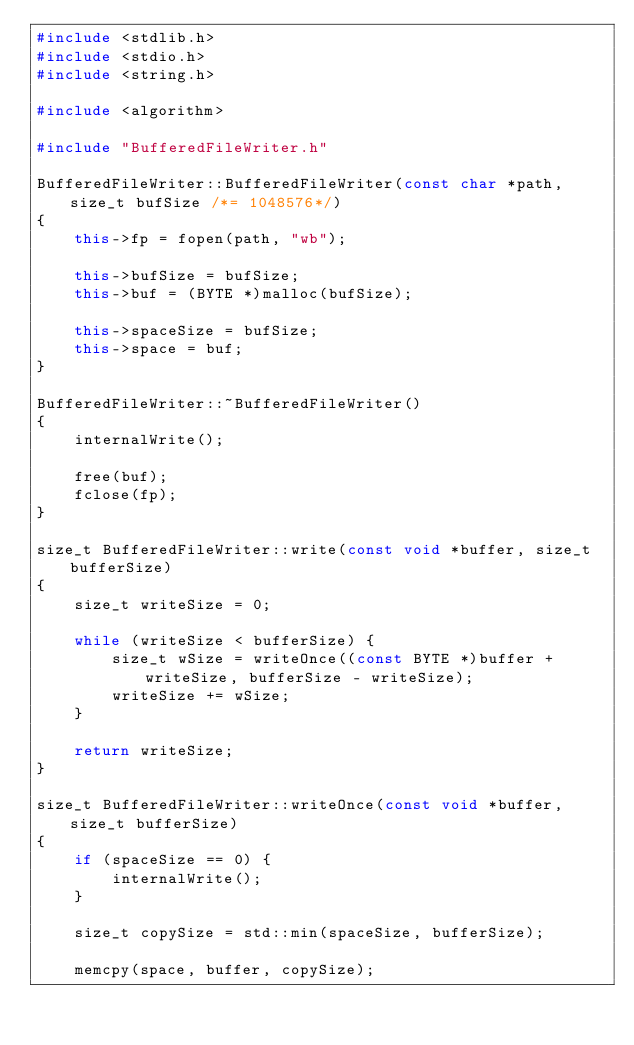Convert code to text. <code><loc_0><loc_0><loc_500><loc_500><_C++_>#include <stdlib.h>
#include <stdio.h>
#include <string.h>

#include <algorithm>

#include "BufferedFileWriter.h"

BufferedFileWriter::BufferedFileWriter(const char *path, size_t bufSize /*= 1048576*/)
{
    this->fp = fopen(path, "wb");

    this->bufSize = bufSize;
    this->buf = (BYTE *)malloc(bufSize);

    this->spaceSize = bufSize;
    this->space = buf;
}

BufferedFileWriter::~BufferedFileWriter()
{
    internalWrite();

    free(buf);
    fclose(fp);
}

size_t BufferedFileWriter::write(const void *buffer, size_t bufferSize)
{
    size_t writeSize = 0;

    while (writeSize < bufferSize) {
        size_t wSize = writeOnce((const BYTE *)buffer + writeSize, bufferSize - writeSize);
        writeSize += wSize;
    }

    return writeSize;
}

size_t BufferedFileWriter::writeOnce(const void *buffer, size_t bufferSize)
{
    if (spaceSize == 0) {
        internalWrite();
    }

    size_t copySize = std::min(spaceSize, bufferSize);

    memcpy(space, buffer, copySize);
</code> 